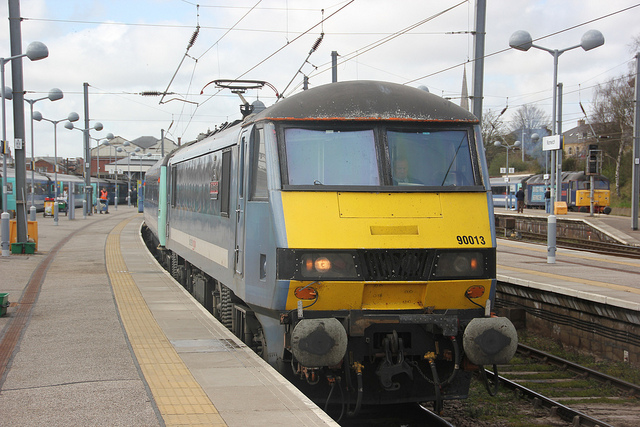Identify the text contained in this image. 90013 